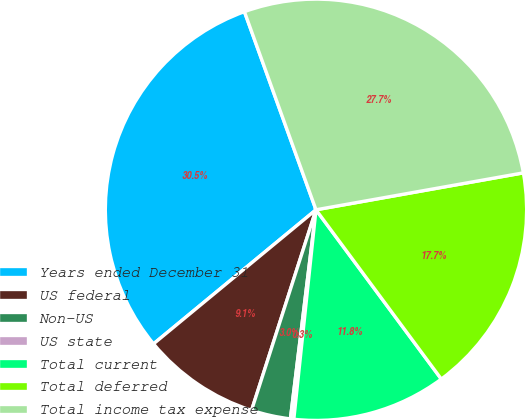Convert chart to OTSL. <chart><loc_0><loc_0><loc_500><loc_500><pie_chart><fcel>Years ended December 31<fcel>US federal<fcel>Non-US<fcel>US state<fcel>Total current<fcel>Total deferred<fcel>Total income tax expense<nl><fcel>30.46%<fcel>9.07%<fcel>3.01%<fcel>0.26%<fcel>11.82%<fcel>17.66%<fcel>27.71%<nl></chart> 